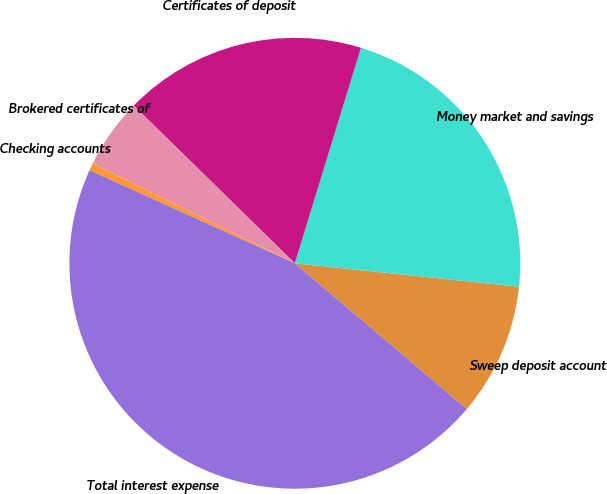Convert chart to OTSL. <chart><loc_0><loc_0><loc_500><loc_500><pie_chart><fcel>Sweep deposit account<fcel>Money market and savings<fcel>Certificates of deposit<fcel>Brokered certificates of<fcel>Checking accounts<fcel>Total interest expense<nl><fcel>9.54%<fcel>21.92%<fcel>17.41%<fcel>5.03%<fcel>0.53%<fcel>45.58%<nl></chart> 